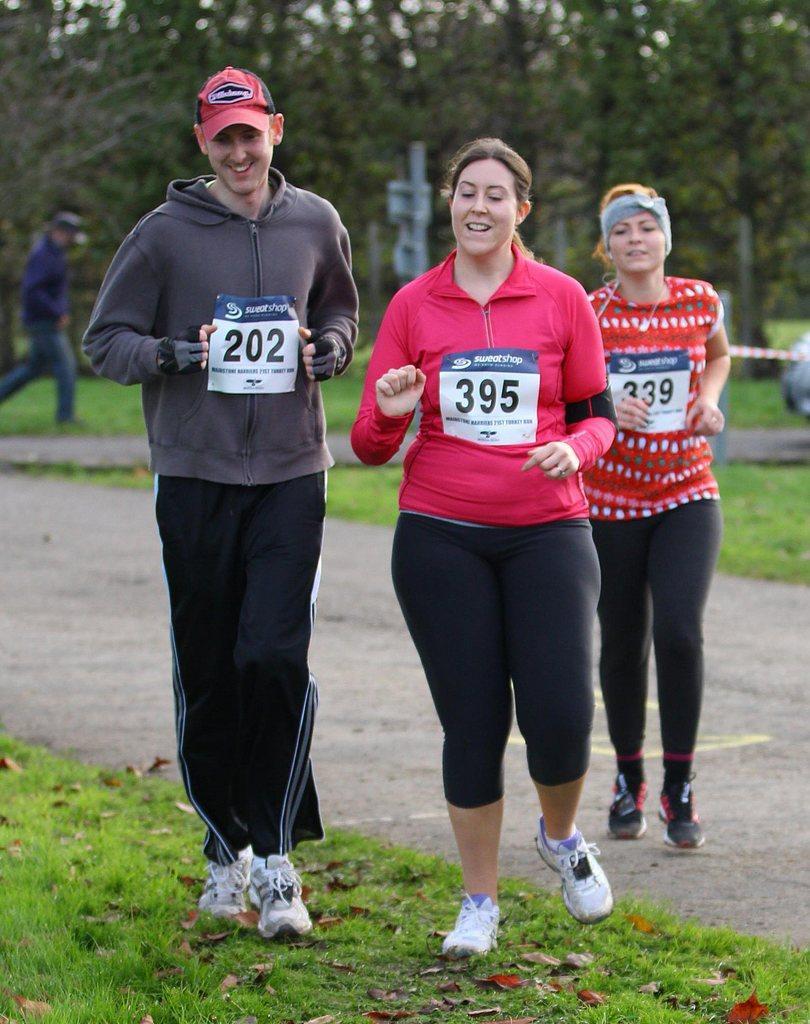Describe this image in one or two sentences. In this image we can see few people running and behind there is a person and we can see grass on the ground and there are some leaves on the ground. There are some trees in the background and the image is blurred. 